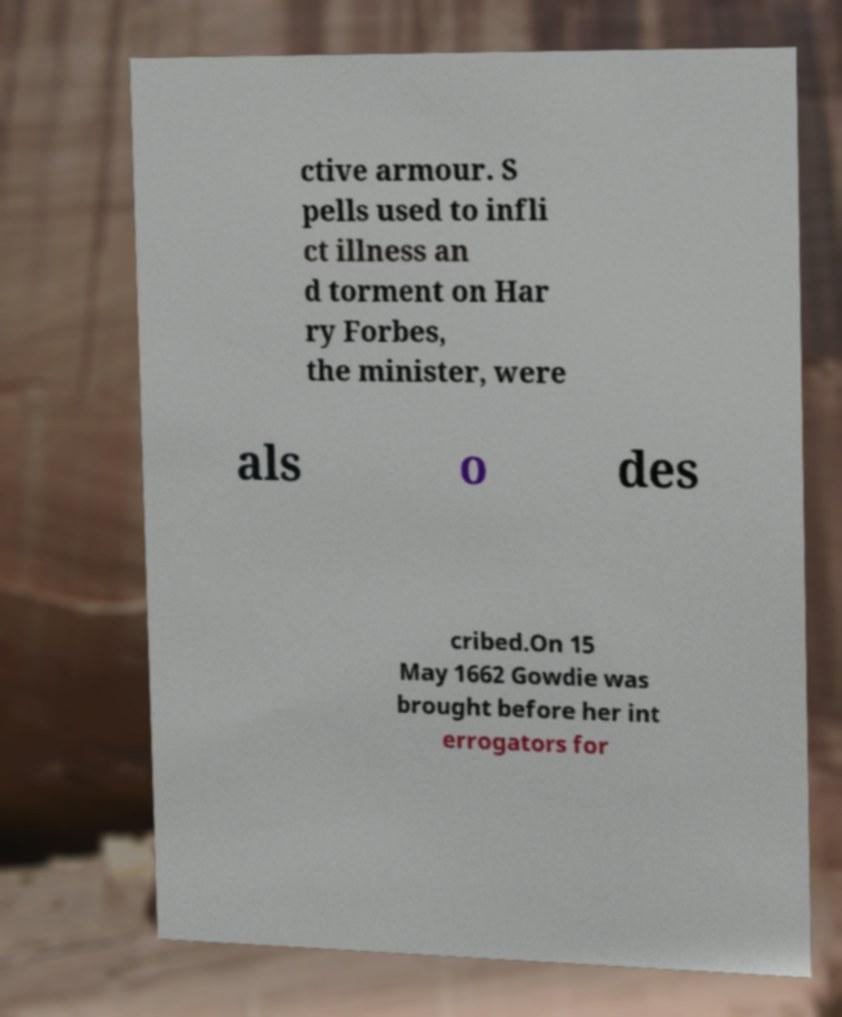Could you extract and type out the text from this image? ctive armour. S pells used to infli ct illness an d torment on Har ry Forbes, the minister, were als o des cribed.On 15 May 1662 Gowdie was brought before her int errogators for 